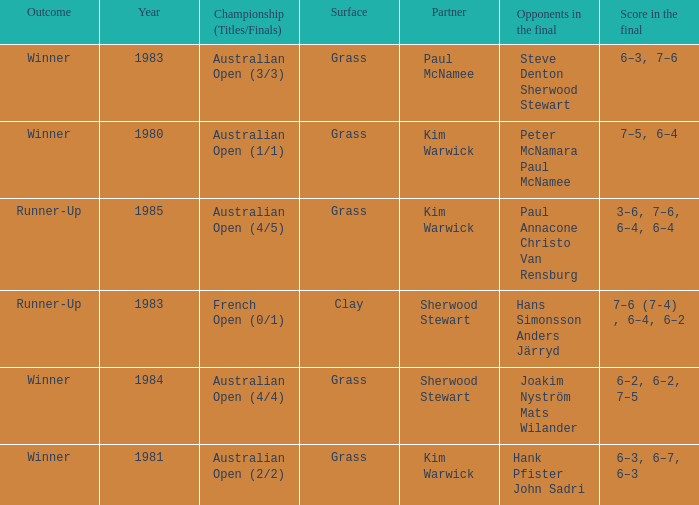How many different outcomes did the final with Paul McNamee as a partner have? 1.0. 